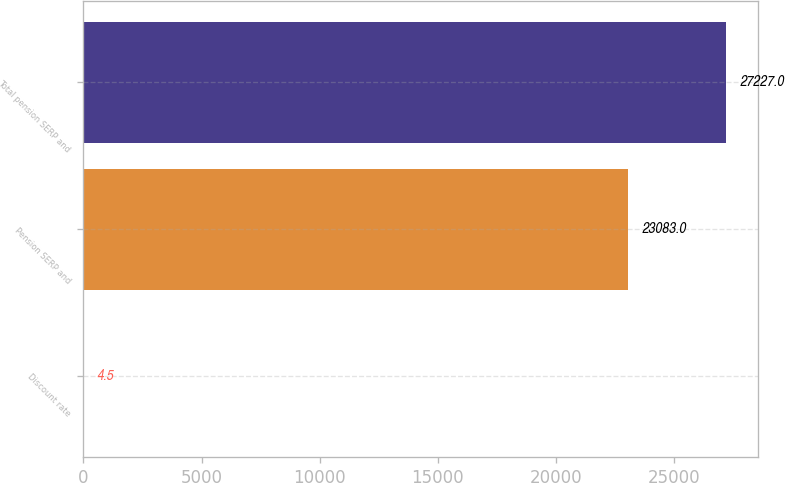Convert chart to OTSL. <chart><loc_0><loc_0><loc_500><loc_500><bar_chart><fcel>Discount rate<fcel>Pension SERP and<fcel>Total pension SERP and<nl><fcel>4.5<fcel>23083<fcel>27227<nl></chart> 